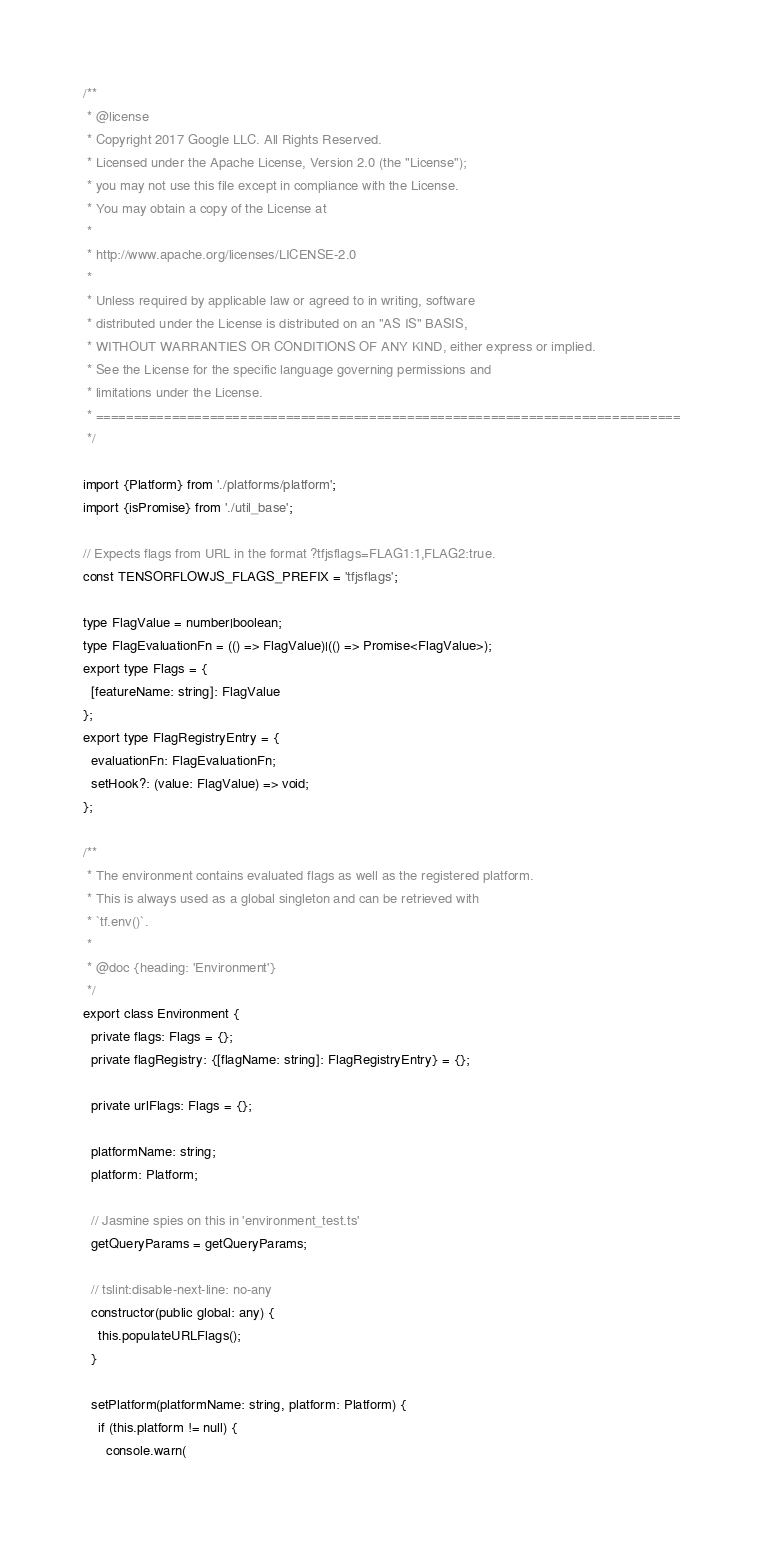Convert code to text. <code><loc_0><loc_0><loc_500><loc_500><_TypeScript_>/**
 * @license
 * Copyright 2017 Google LLC. All Rights Reserved.
 * Licensed under the Apache License, Version 2.0 (the "License");
 * you may not use this file except in compliance with the License.
 * You may obtain a copy of the License at
 *
 * http://www.apache.org/licenses/LICENSE-2.0
 *
 * Unless required by applicable law or agreed to in writing, software
 * distributed under the License is distributed on an "AS IS" BASIS,
 * WITHOUT WARRANTIES OR CONDITIONS OF ANY KIND, either express or implied.
 * See the License for the specific language governing permissions and
 * limitations under the License.
 * =============================================================================
 */

import {Platform} from './platforms/platform';
import {isPromise} from './util_base';

// Expects flags from URL in the format ?tfjsflags=FLAG1:1,FLAG2:true.
const TENSORFLOWJS_FLAGS_PREFIX = 'tfjsflags';

type FlagValue = number|boolean;
type FlagEvaluationFn = (() => FlagValue)|(() => Promise<FlagValue>);
export type Flags = {
  [featureName: string]: FlagValue
};
export type FlagRegistryEntry = {
  evaluationFn: FlagEvaluationFn;
  setHook?: (value: FlagValue) => void;
};

/**
 * The environment contains evaluated flags as well as the registered platform.
 * This is always used as a global singleton and can be retrieved with
 * `tf.env()`.
 *
 * @doc {heading: 'Environment'}
 */
export class Environment {
  private flags: Flags = {};
  private flagRegistry: {[flagName: string]: FlagRegistryEntry} = {};

  private urlFlags: Flags = {};

  platformName: string;
  platform: Platform;

  // Jasmine spies on this in 'environment_test.ts'
  getQueryParams = getQueryParams;

  // tslint:disable-next-line: no-any
  constructor(public global: any) {
    this.populateURLFlags();
  }

  setPlatform(platformName: string, platform: Platform) {
    if (this.platform != null) {
      console.warn(</code> 